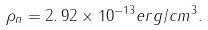<formula> <loc_0><loc_0><loc_500><loc_500>\rho _ { n } = 2 . \, 9 2 \times 1 0 ^ { - 1 3 } e r g / c m ^ { 3 } .</formula> 